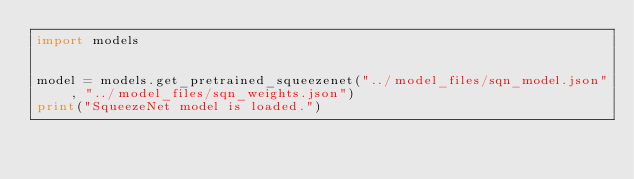<code> <loc_0><loc_0><loc_500><loc_500><_Python_>import models


model = models.get_pretrained_squeezenet("../model_files/sqn_model.json", "../model_files/sqn_weights.json")
print("SqueezeNet model is loaded.")</code> 